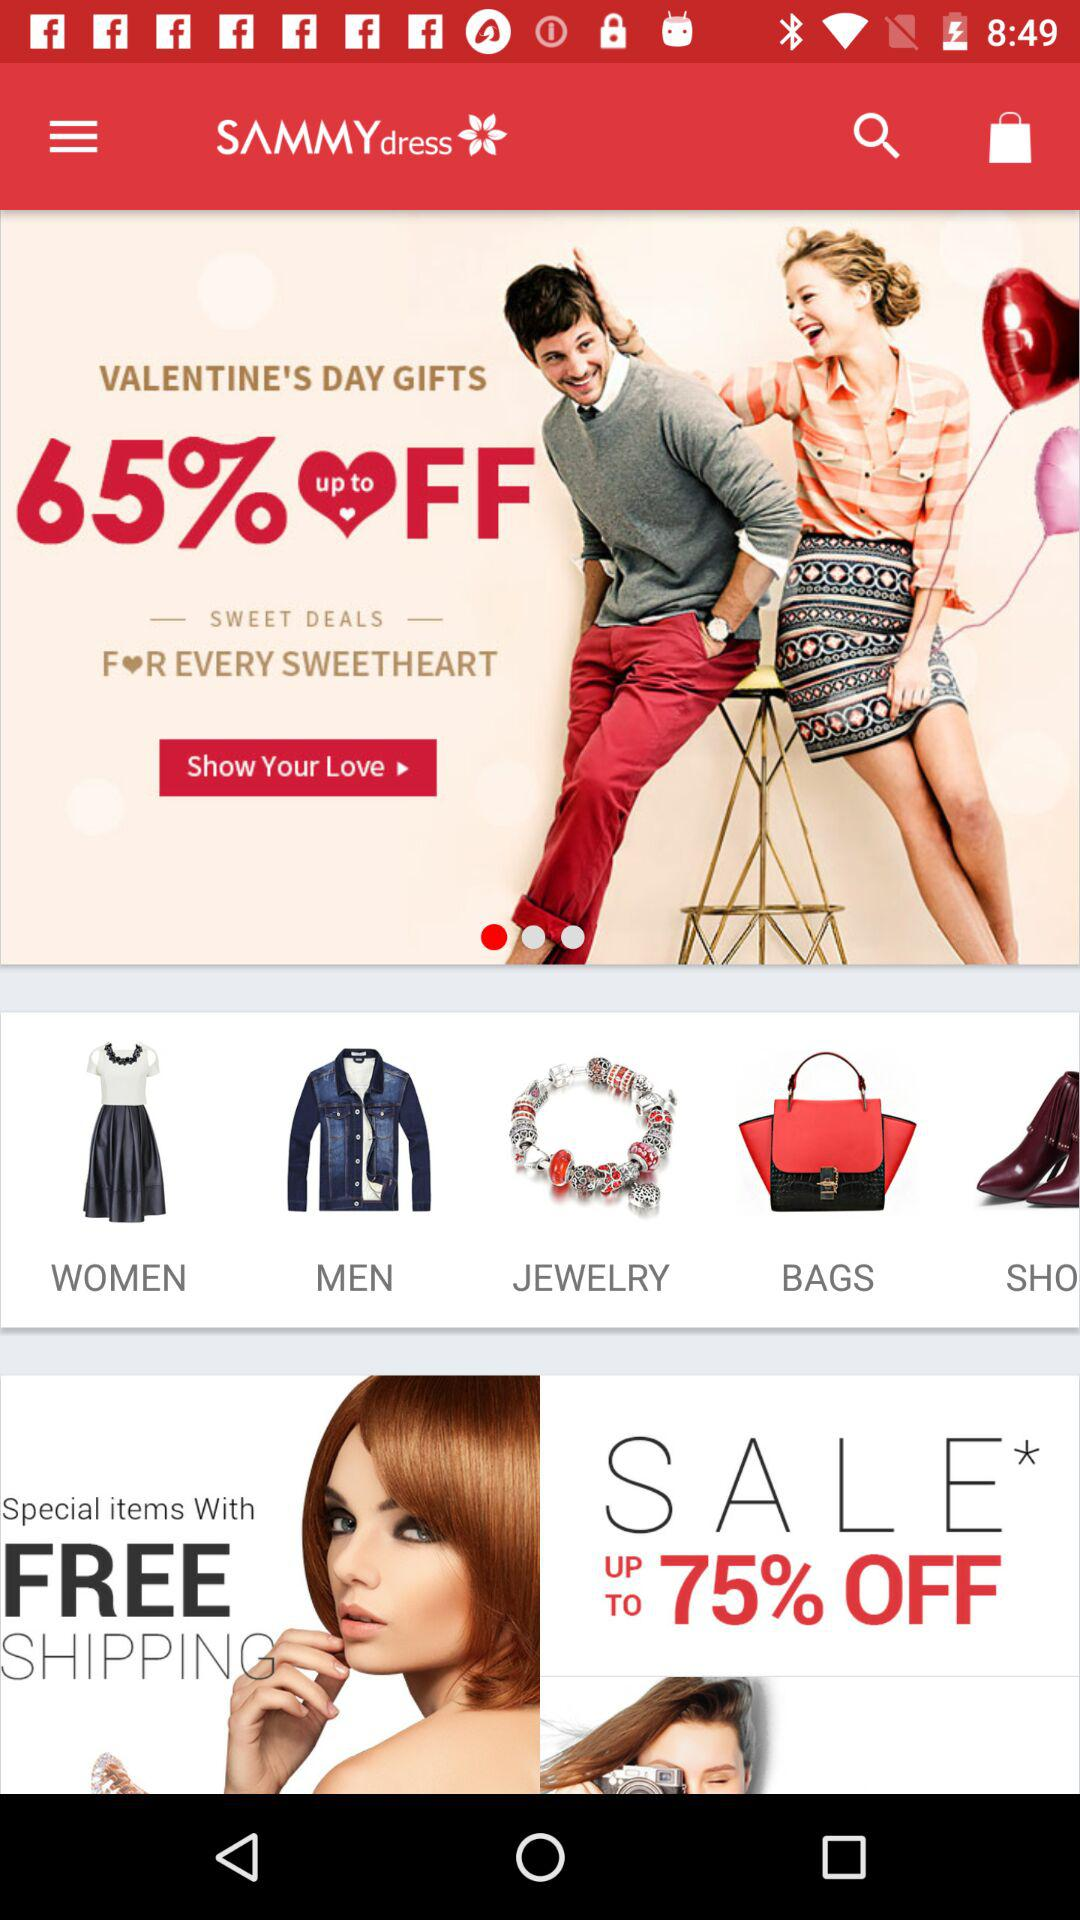What is the application name? The application name is "SAMMYdress". 